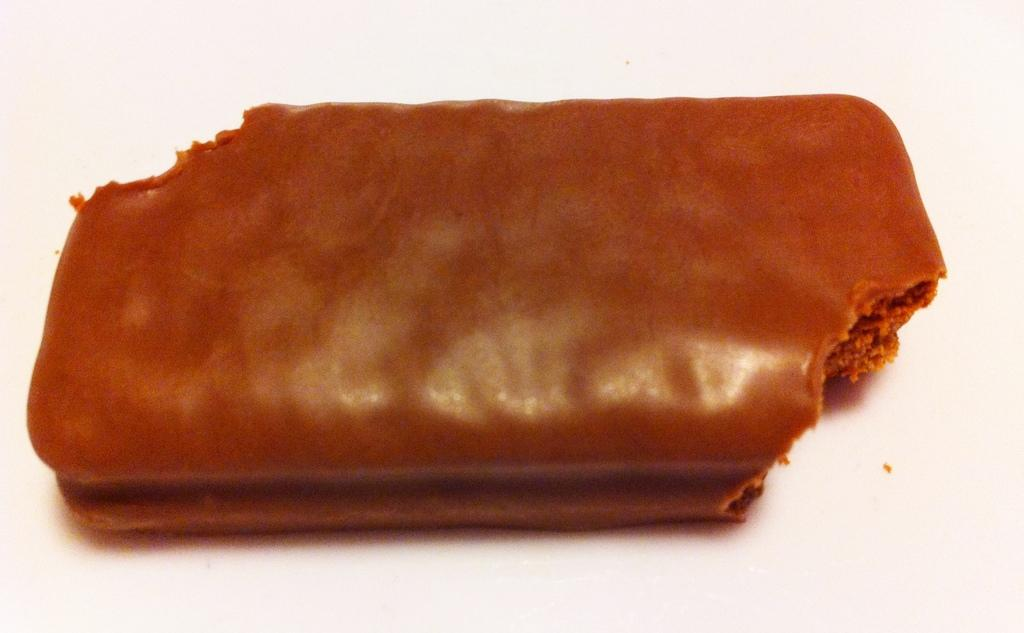What type of food is partially consumed in the image? There is a half-eaten chocolate in the image. What type of vessel is being used to hold the chocolate in the image? There is no vessel present in the image; the chocolate is not being held in any container. Whose hands can be seen holding the chocolate in the image? There are no hands visible in the image; only the half-eaten chocolate is present. Is the person who ate the chocolate in the image the father of the person taking the photo? There is no person present in the image, only the half-eaten chocolate, so it is impossible to determine the relationship between the person who ate the chocolate and the person taking the photo. 